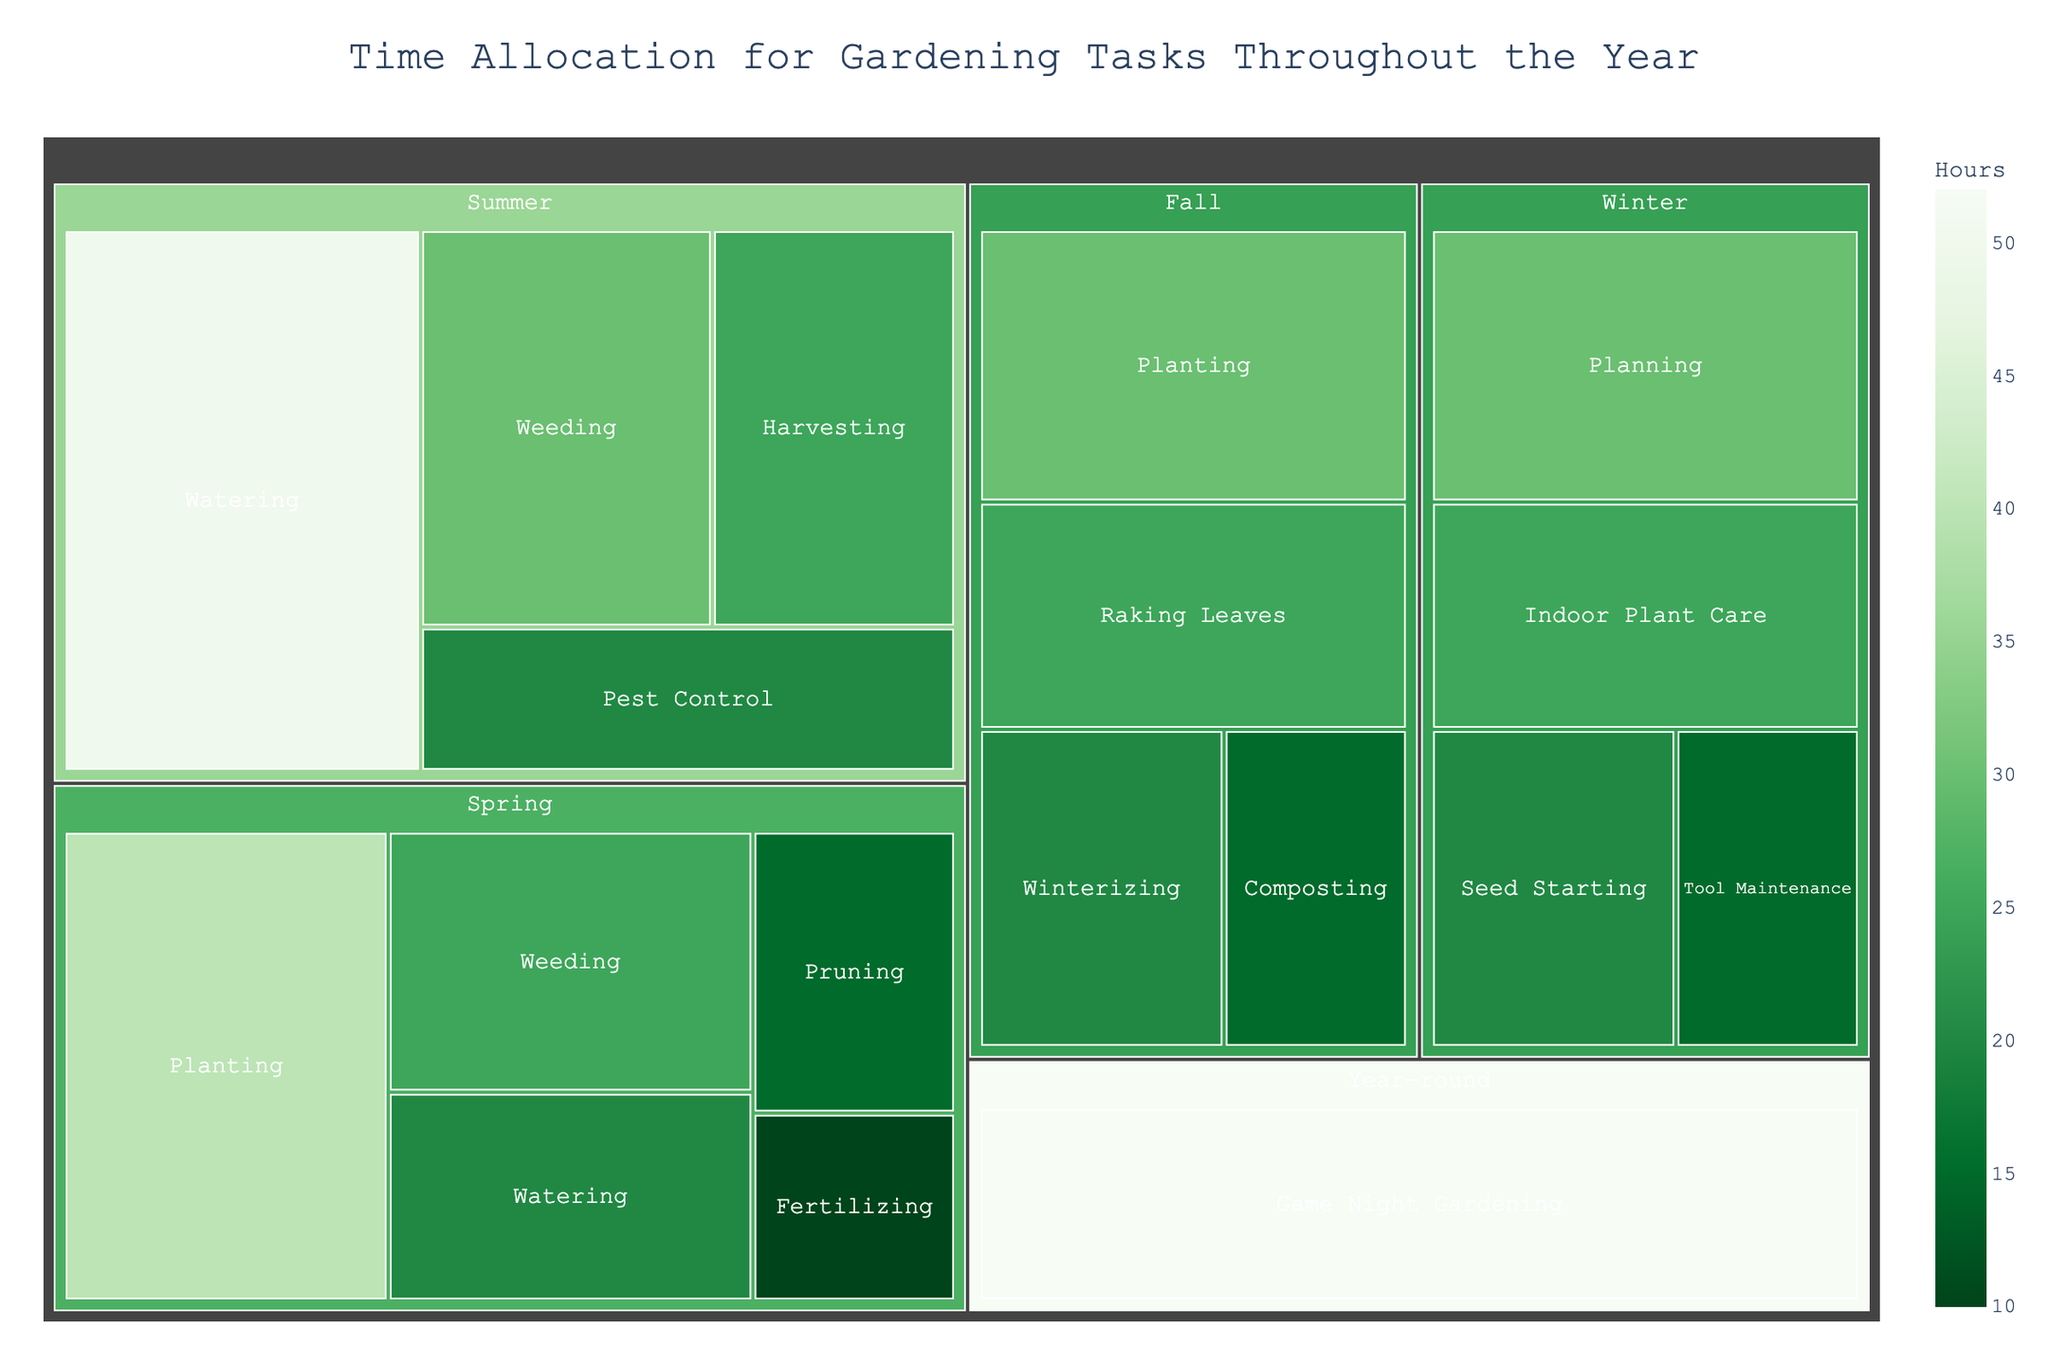what is the title of the plot? The title of the plot is displayed prominently at the top of the treemap. The title summarizes the overall theme or focus of the visualization.
Answer: Time Allocation for Gardening Tasks Throughout the Year Which season has the highest total hours for gardening tasks? By examining the size of the blocks within each season, you can visually compare which season has the largest cumulative area. Since "Summer" has sizable blocks for tasks like "Watering" and "Weeding," it likely sums to the highest total.
Answer: Summer How many hours are spent on "Weeding" during "Spring"? Locate the "Spring" section on the treemap, then find the "Weeding" task within it. The hours for each task are labeled or can be inferred from the size of the block.
Answer: 25 Which task occupies the most time in "Fall"? Look under the "Fall" section. The task with the largest block represents the highest number of hours spent.
Answer: Planting What is the combined time spent on "Planning" and "Indoor Plant Care" during "Winter"? Sum the hours spent on "Planning" (30) and "Indoor Plant Care" (25) as indicated within the "Winter" section of the treemap.
Answer: 55 hours Compare the time spent on "Planting" in "Spring" and "Fall" Locate the "Planting" blocks in both the "Spring" and "Fall" sections. Compare their sizes or the labeled hours.
Answer: Spring: 40 hours, Fall: 30 hours Which task is allocated the least amount of time throughout the year? By identifying the smallest block in the entire treemap, you can determine the task with the least hours.
Answer: Fertilizing in Spring How many tasks are performed year-round? Find the section labeled "Year-round" and count the tasks within it.
Answer: 1 What is the difference between hours spent on "Watering" in "Spring" and "Summer"? Subtract the hours for "Watering" in "Spring" (20) from the hours for "Watering" in "Summer" (50).
Answer: 30 hours Which "Winter" task has the second highest number of hours? In the "Winter" section, identify and rank the tasks by their hours. The second highest should be the next largest block after the highest one.
Answer: Indoor Plant Care 